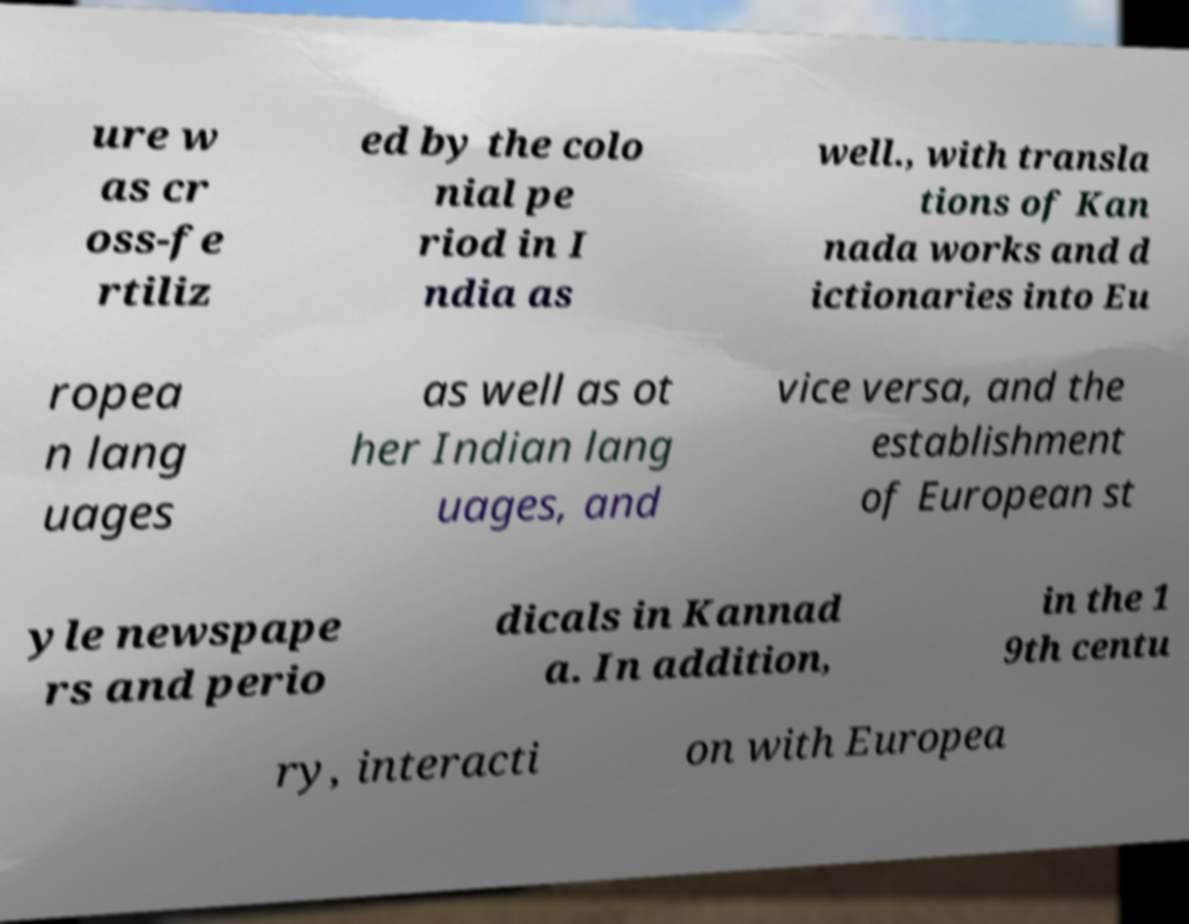I need the written content from this picture converted into text. Can you do that? ure w as cr oss-fe rtiliz ed by the colo nial pe riod in I ndia as well., with transla tions of Kan nada works and d ictionaries into Eu ropea n lang uages as well as ot her Indian lang uages, and vice versa, and the establishment of European st yle newspape rs and perio dicals in Kannad a. In addition, in the 1 9th centu ry, interacti on with Europea 